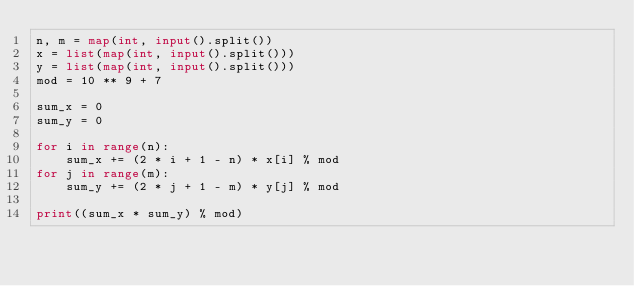<code> <loc_0><loc_0><loc_500><loc_500><_Python_>n, m = map(int, input().split())
x = list(map(int, input().split()))
y = list(map(int, input().split()))
mod = 10 ** 9 + 7

sum_x = 0
sum_y = 0

for i in range(n):
    sum_x += (2 * i + 1 - n) * x[i] % mod
for j in range(m):
    sum_y += (2 * j + 1 - m) * y[j] % mod

print((sum_x * sum_y) % mod)
</code> 